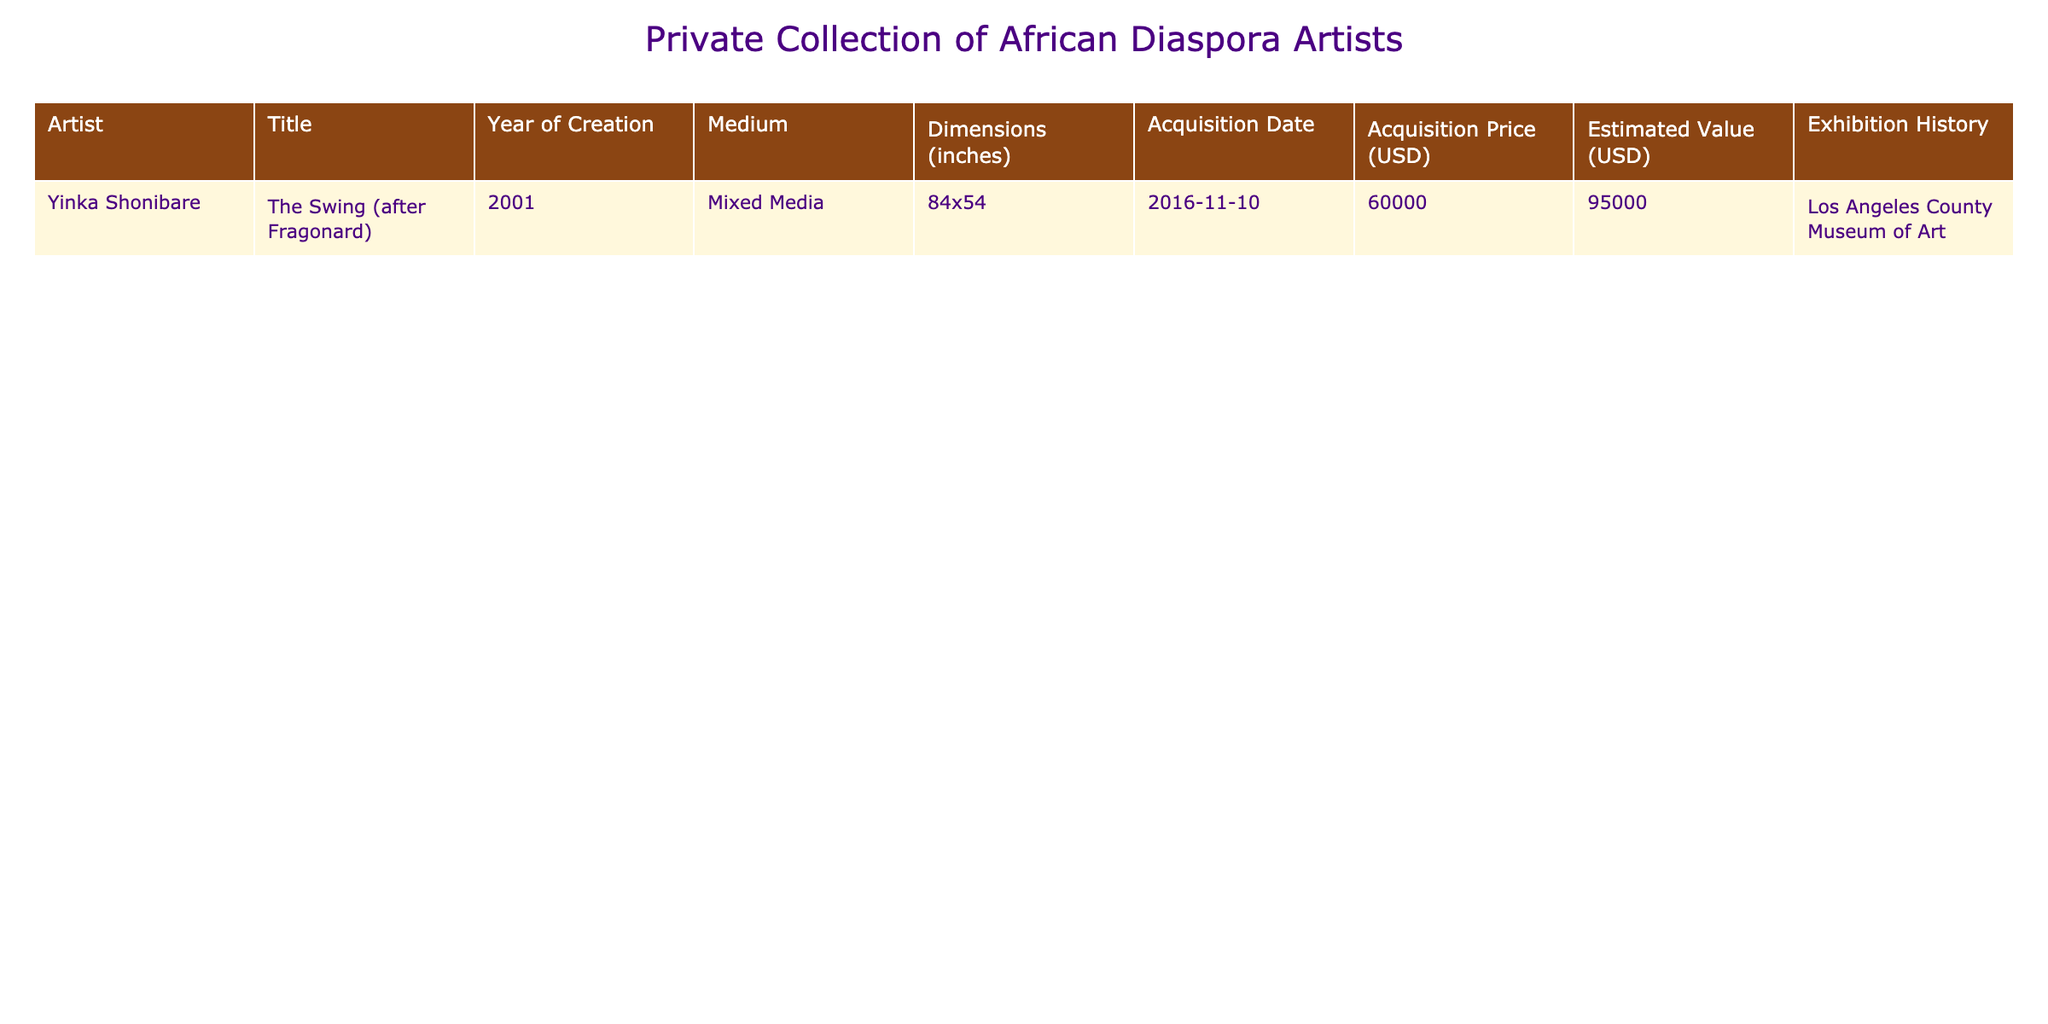What is the title of the artwork by Yinka Shonibare? The table lists the artwork created by Yinka Shonibare, and the title in the corresponding row is "The Swing (after Fragonard)".
Answer: "The Swing (after Fragonard)" What year was "The Swing (after Fragonard)" created? The table shows the creation year of the artwork, and according to the data, it was created in the year 2001.
Answer: 2001 What is the estimated value of the artwork? The estimated value is provided in the table for the artwork by Yinka Shonibare, which is listed as 95,000 USD.
Answer: 95,000 USD What medium is used in Yinka Shonibare's artwork? The table specifies the medium of the artwork, which is described as Mixed Media.
Answer: Mixed Media What are the dimensions of the artwork? By looking at the dimensions column in the table, the dimensions of the artwork are 84x54 inches.
Answer: 84x54 inches How much was the acquisition price for the artwork? The acquisition price is directly available in the table, which indicates it was purchased for 60,000 USD.
Answer: 60,000 USD Was the artwork exhibited at the Los Angeles County Museum of Art? The exhibition history in the table states that the artwork was indeed exhibited at the Los Angeles County Museum of Art, confirming a yes.
Answer: Yes What is the difference between the estimated value and the acquisition price? To find the difference, subtract the acquisition price (60,000 USD) from the estimated value (95,000 USD): 95,000 - 60,000 = 35,000.
Answer: 35,000 USD If the artwork were to sell for its estimated value, what would the profit be based on the acquisition price? The profit can be calculated by taking the estimated value (95,000 USD) and subtracting the acquisition price (60,000 USD). The calculation results in 95,000 - 60,000 = 35,000 USD profit.
Answer: 35,000 USD Is there any artwork in the collection that is valued over 100,000 USD? No, by reviewing the table, we see that the highest estimated value listed for any artwork is 95,000 USD, which is below 100,000 USD.
Answer: No 